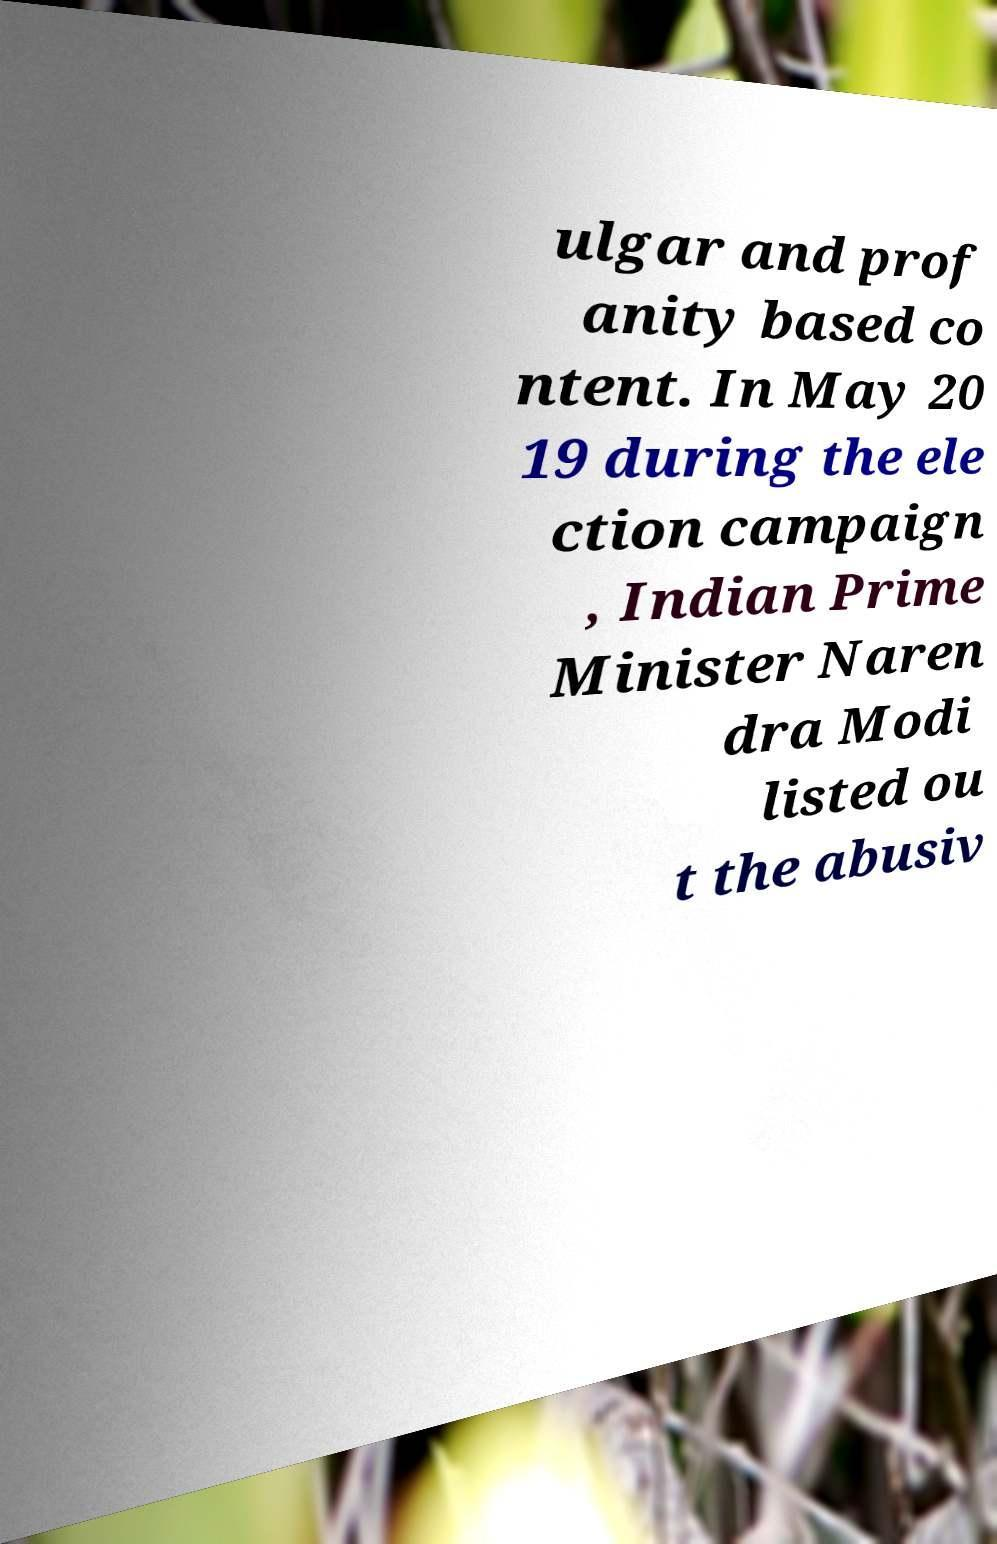Could you extract and type out the text from this image? ulgar and prof anity based co ntent. In May 20 19 during the ele ction campaign , Indian Prime Minister Naren dra Modi listed ou t the abusiv 